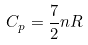Convert formula to latex. <formula><loc_0><loc_0><loc_500><loc_500>C _ { p } = \frac { 7 } { 2 } n R</formula> 